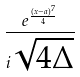<formula> <loc_0><loc_0><loc_500><loc_500>\frac { e ^ { \frac { ( x - a ) ^ { 7 } } { 4 } } } { i \sqrt { 4 \Delta } }</formula> 